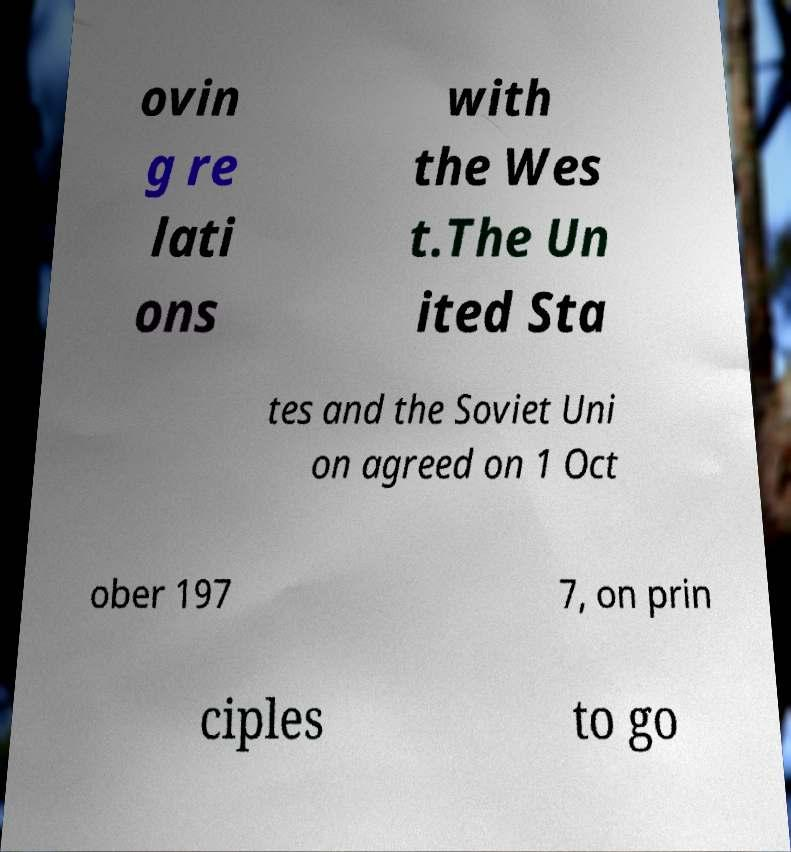Please read and relay the text visible in this image. What does it say? ovin g re lati ons with the Wes t.The Un ited Sta tes and the Soviet Uni on agreed on 1 Oct ober 197 7, on prin ciples to go 